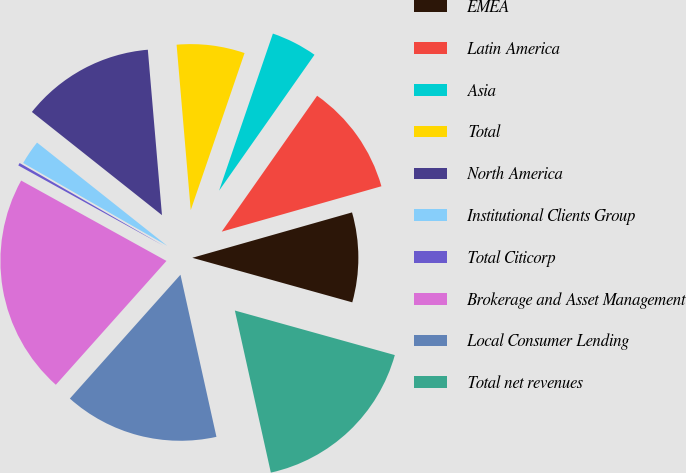<chart> <loc_0><loc_0><loc_500><loc_500><pie_chart><fcel>EMEA<fcel>Latin America<fcel>Asia<fcel>Total<fcel>North America<fcel>Institutional Clients Group<fcel>Total Citicorp<fcel>Brokerage and Asset Management<fcel>Local Consumer Lending<fcel>Total net revenues<nl><fcel>8.73%<fcel>10.85%<fcel>4.49%<fcel>6.61%<fcel>12.97%<fcel>2.37%<fcel>0.26%<fcel>21.44%<fcel>15.08%<fcel>17.2%<nl></chart> 